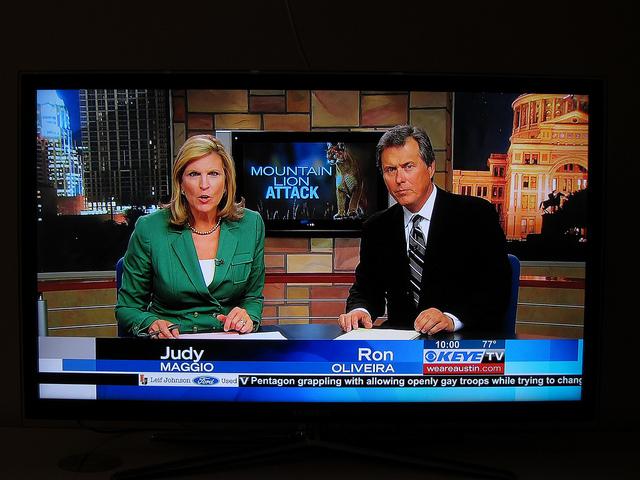What show is the man on?
Short answer required. News. Is this on a television?
Answer briefly. Yes. What time is it on the TV?
Write a very short answer. 10:00. What body part is visible in this photo?
Keep it brief. Torso. What type of animal attacked?
Keep it brief. Mountain lion. What temperature is listed on the screen?
Short answer required. 77. Is the presenter pierced?
Answer briefly. Yes. What do the words on the screen say?
Quick response, please. Keye tv. Could she be a beautician?
Short answer required. No. What country is this in?
Answer briefly. Usa. Who are the man and woman in the picture?
Quick response, please. Newscasters. 